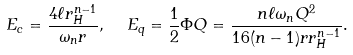Convert formula to latex. <formula><loc_0><loc_0><loc_500><loc_500>E _ { c } = \frac { 4 \ell r _ { H } ^ { n - 1 } } { \omega _ { n } r } , \ \ E _ { q } = \frac { 1 } { 2 } \Phi Q = \frac { n \ell \omega _ { n } Q ^ { 2 } } { 1 6 ( n - 1 ) r r _ { H } ^ { n - 1 } } .</formula> 